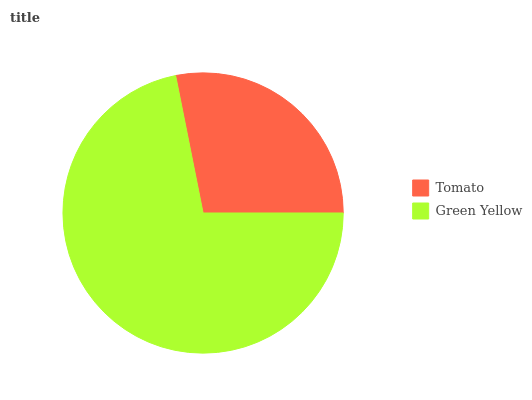Is Tomato the minimum?
Answer yes or no. Yes. Is Green Yellow the maximum?
Answer yes or no. Yes. Is Green Yellow the minimum?
Answer yes or no. No. Is Green Yellow greater than Tomato?
Answer yes or no. Yes. Is Tomato less than Green Yellow?
Answer yes or no. Yes. Is Tomato greater than Green Yellow?
Answer yes or no. No. Is Green Yellow less than Tomato?
Answer yes or no. No. Is Green Yellow the high median?
Answer yes or no. Yes. Is Tomato the low median?
Answer yes or no. Yes. Is Tomato the high median?
Answer yes or no. No. Is Green Yellow the low median?
Answer yes or no. No. 